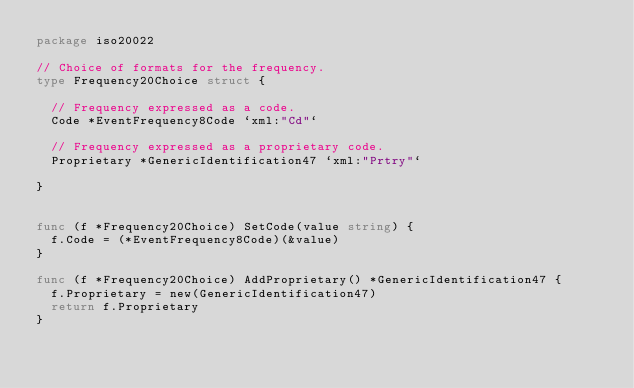<code> <loc_0><loc_0><loc_500><loc_500><_Go_>package iso20022

// Choice of formats for the frequency.
type Frequency20Choice struct {

	// Frequency expressed as a code.
	Code *EventFrequency8Code `xml:"Cd"`

	// Frequency expressed as a proprietary code.
	Proprietary *GenericIdentification47 `xml:"Prtry"`

}


func (f *Frequency20Choice) SetCode(value string) {
	f.Code = (*EventFrequency8Code)(&value)
}

func (f *Frequency20Choice) AddProprietary() *GenericIdentification47 {
	f.Proprietary = new(GenericIdentification47)
	return f.Proprietary
}

</code> 